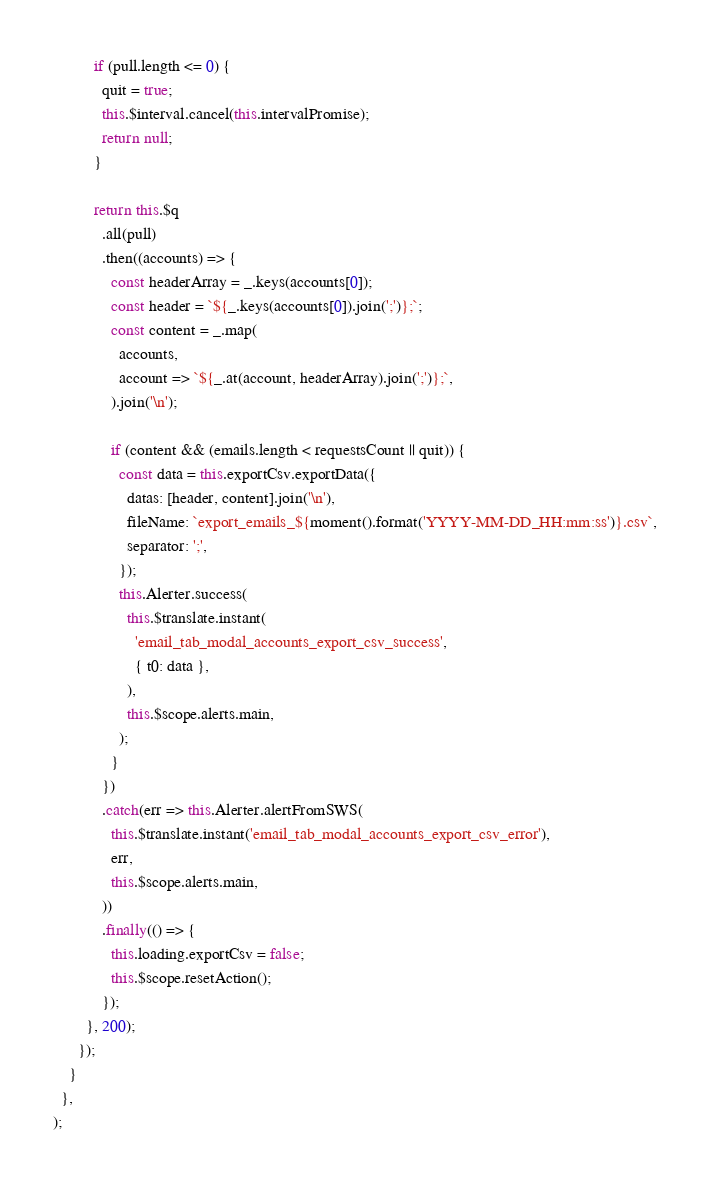Convert code to text. <code><loc_0><loc_0><loc_500><loc_500><_JavaScript_>          if (pull.length <= 0) {
            quit = true;
            this.$interval.cancel(this.intervalPromise);
            return null;
          }

          return this.$q
            .all(pull)
            .then((accounts) => {
              const headerArray = _.keys(accounts[0]);
              const header = `${_.keys(accounts[0]).join(';')};`;
              const content = _.map(
                accounts,
                account => `${_.at(account, headerArray).join(';')};`,
              ).join('\n');

              if (content && (emails.length < requestsCount || quit)) {
                const data = this.exportCsv.exportData({
                  datas: [header, content].join('\n'),
                  fileName: `export_emails_${moment().format('YYYY-MM-DD_HH:mm:ss')}.csv`,
                  separator: ';',
                });
                this.Alerter.success(
                  this.$translate.instant(
                    'email_tab_modal_accounts_export_csv_success',
                    { t0: data },
                  ),
                  this.$scope.alerts.main,
                );
              }
            })
            .catch(err => this.Alerter.alertFromSWS(
              this.$translate.instant('email_tab_modal_accounts_export_csv_error'),
              err,
              this.$scope.alerts.main,
            ))
            .finally(() => {
              this.loading.exportCsv = false;
              this.$scope.resetAction();
            });
        }, 200);
      });
    }
  },
);
</code> 